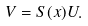Convert formula to latex. <formula><loc_0><loc_0><loc_500><loc_500>V = S ( x ) U .</formula> 